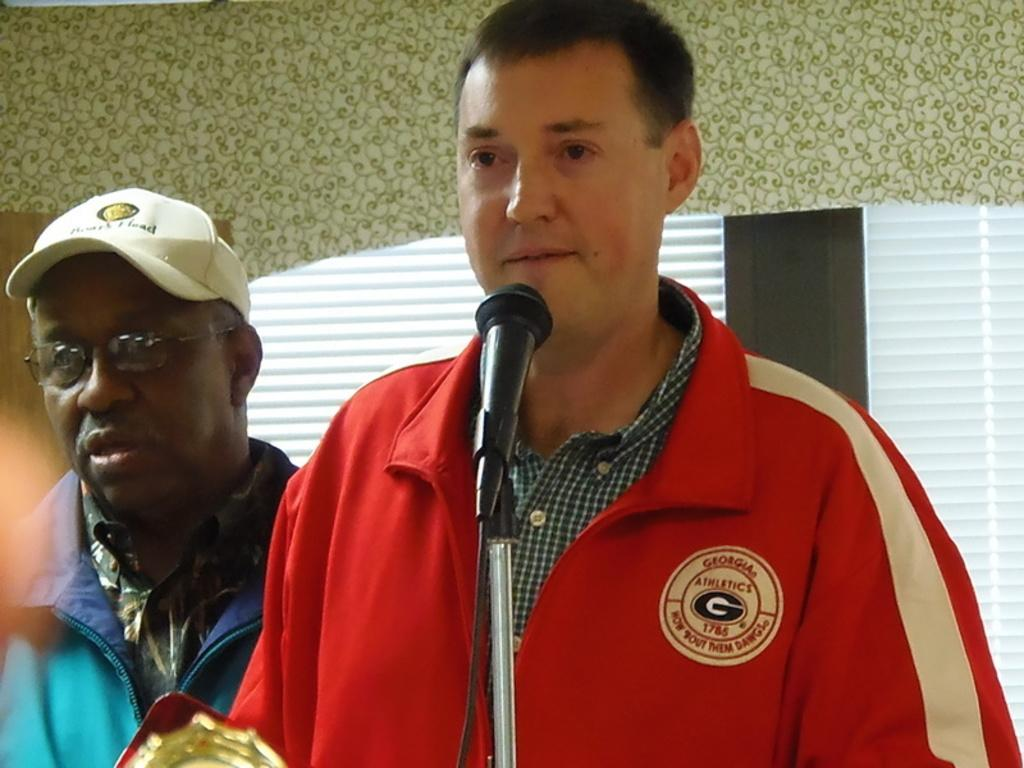What is the main subject of the image? There is a person standing at the mic in the center of the image. Can you describe the other person in the image? There is another person on the left side of the image. What can be seen in the background of the image? There is a wall and a window in the background of the image. What type of wren can be seen perched on the window in the image? There is no wren present in the image; the window is part of the background and does not have any birds perched on it. 